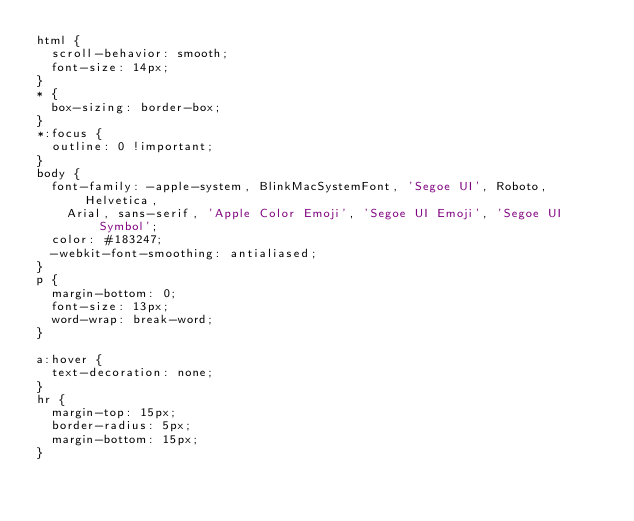<code> <loc_0><loc_0><loc_500><loc_500><_CSS_>html {
  scroll-behavior: smooth;
  font-size: 14px;
}
* {
  box-sizing: border-box;
}
*:focus {
  outline: 0 !important;
}
body {
  font-family: -apple-system, BlinkMacSystemFont, 'Segoe UI', Roboto, Helvetica,
    Arial, sans-serif, 'Apple Color Emoji', 'Segoe UI Emoji', 'Segoe UI Symbol';
  color: #183247;
  -webkit-font-smoothing: antialiased;
}
p {
  margin-bottom: 0;
  font-size: 13px;
  word-wrap: break-word;
}

a:hover {
  text-decoration: none;
}
hr {
  margin-top: 15px;
  border-radius: 5px;
  margin-bottom: 15px;
}
</code> 